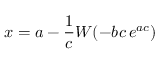Convert formula to latex. <formula><loc_0><loc_0><loc_500><loc_500>x = a - { \frac { 1 } { c } } W ( - b c \, e ^ { a c } )</formula> 